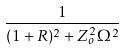Convert formula to latex. <formula><loc_0><loc_0><loc_500><loc_500>\frac { 1 } { ( 1 + R ) ^ { 2 } + Z _ { o } ^ { 2 } \Omega ^ { 2 } }</formula> 